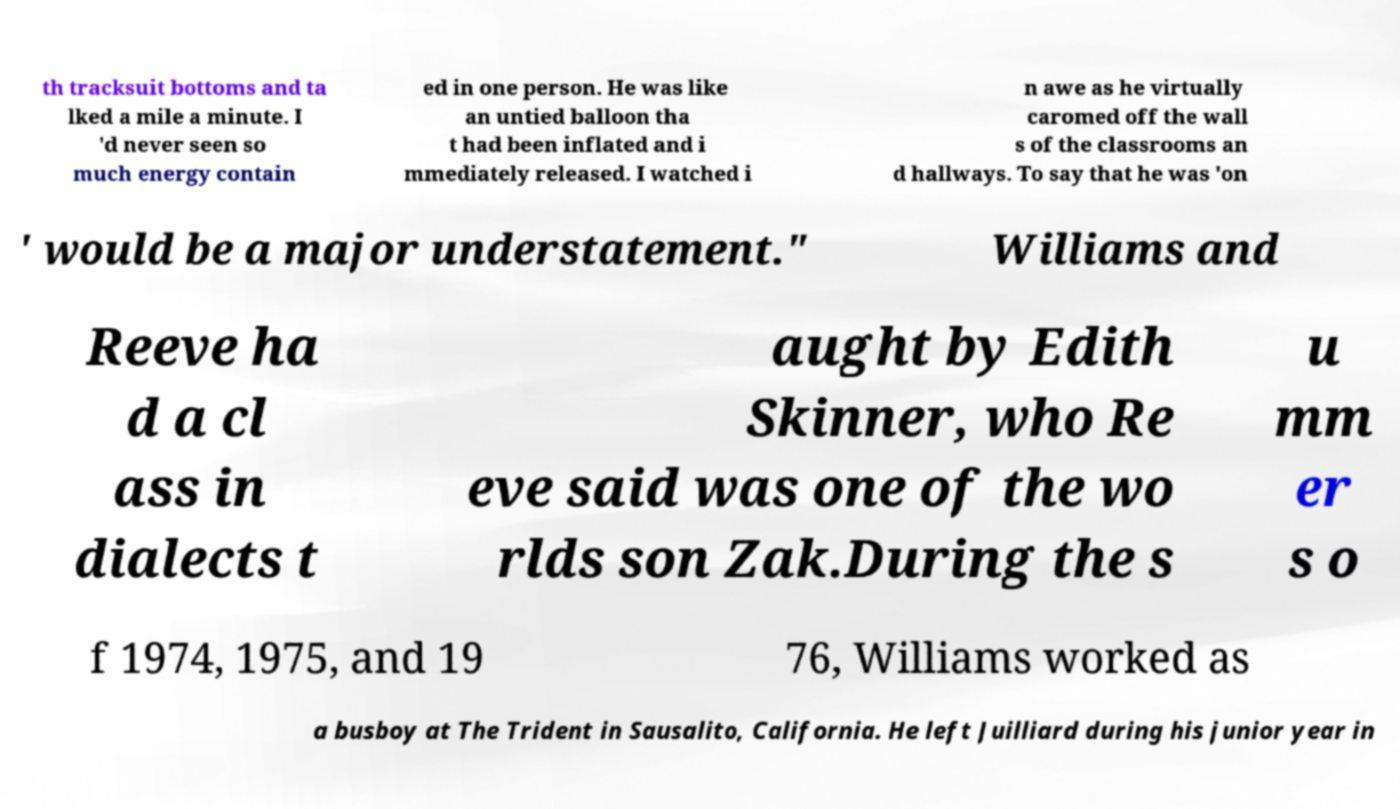There's text embedded in this image that I need extracted. Can you transcribe it verbatim? th tracksuit bottoms and ta lked a mile a minute. I 'd never seen so much energy contain ed in one person. He was like an untied balloon tha t had been inflated and i mmediately released. I watched i n awe as he virtually caromed off the wall s of the classrooms an d hallways. To say that he was 'on ' would be a major understatement." Williams and Reeve ha d a cl ass in dialects t aught by Edith Skinner, who Re eve said was one of the wo rlds son Zak.During the s u mm er s o f 1974, 1975, and 19 76, Williams worked as a busboy at The Trident in Sausalito, California. He left Juilliard during his junior year in 